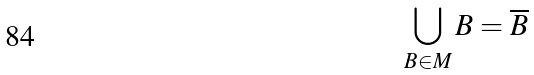<formula> <loc_0><loc_0><loc_500><loc_500>\bigcup _ { B \in M } B = \overline { B }</formula> 